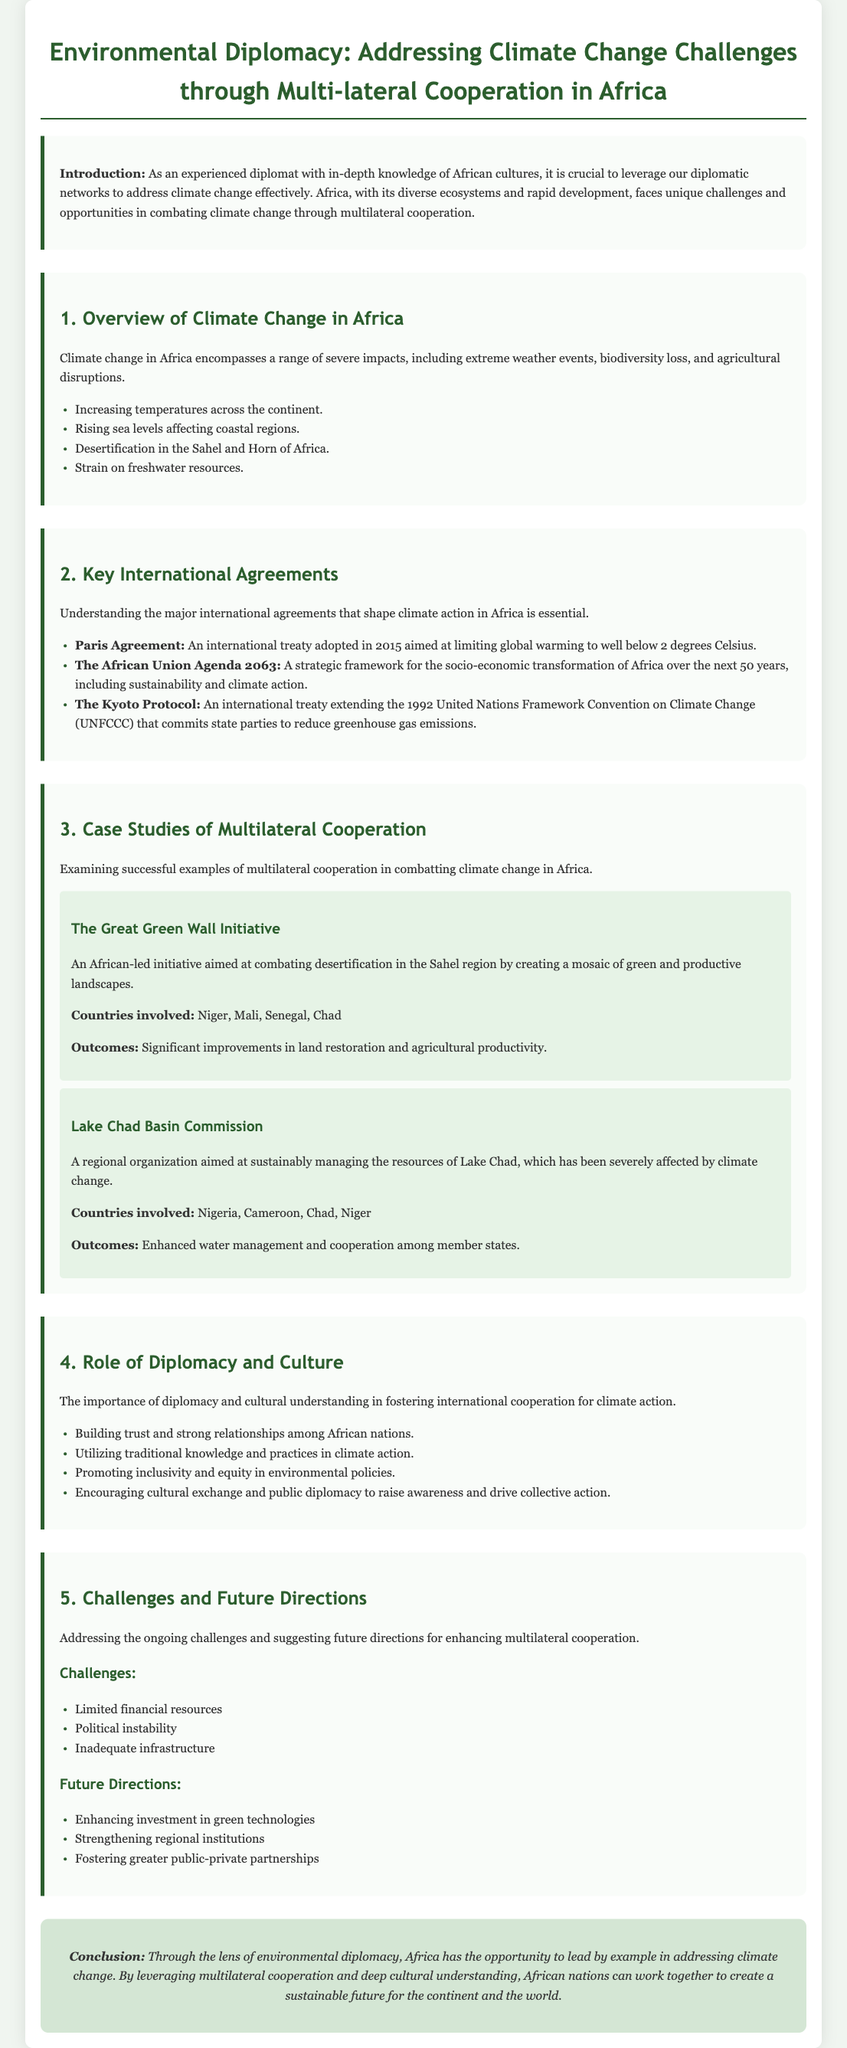What is the focus of the document? The document highlights how environmental diplomacy can address climate change challenges through multilateral cooperation in Africa.
Answer: Environmental Diplomacy What are two severe impacts of climate change in Africa? The document lists extreme weather events and biodiversity loss as severe impacts of climate change in Africa.
Answer: Extreme weather events, biodiversity loss What is the main goal of the Paris Agreement? The Paris Agreement aims to limit global warming to well below 2 degrees Celsius.
Answer: Limit global warming to well below 2 degrees Celsius Which initiative is aimed at combating desertification in the Sahel region? The Great Green Wall Initiative is specifically mentioned as the initiative aimed at addressing desertification in the Sahel.
Answer: The Great Green Wall Initiative How many countries are involved in the Lake Chad Basin Commission? The document specifies four countries are involved in the Lake Chad Basin Commission.
Answer: Four What challenge related to climate action does the document mention? The document lists limited financial resources as one of the challenges related to climate action.
Answer: Limited financial resources What is a future direction mentioned for enhancing multilateral cooperation? The document suggests strengthening regional institutions as a future direction for improving multilateral cooperation.
Answer: Strengthening regional institutions In which section is the case study of the Great Green Wall Initiative discussed? The case study of the Great Green Wall Initiative is discussed in section 3 titled "Case Studies of Multilateral Cooperation."
Answer: Section 3 What does the conclusion emphasize about Africa? The conclusion emphasizes that Africa has the opportunity to lead by example in addressing climate change.
Answer: Lead by example 